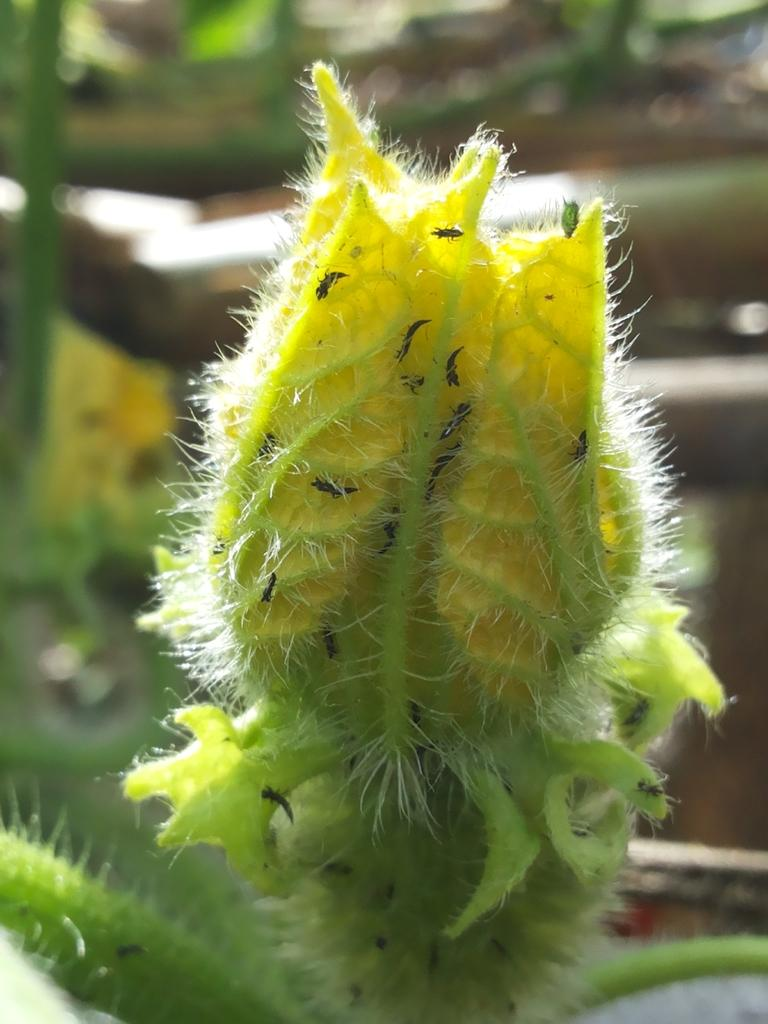What is the main subject of the image? There is a flower in the image. How many deer are visible in the image? There are no deer present in the image; it features a flower. What shape is the wax in the image? There is no wax present in the image. 